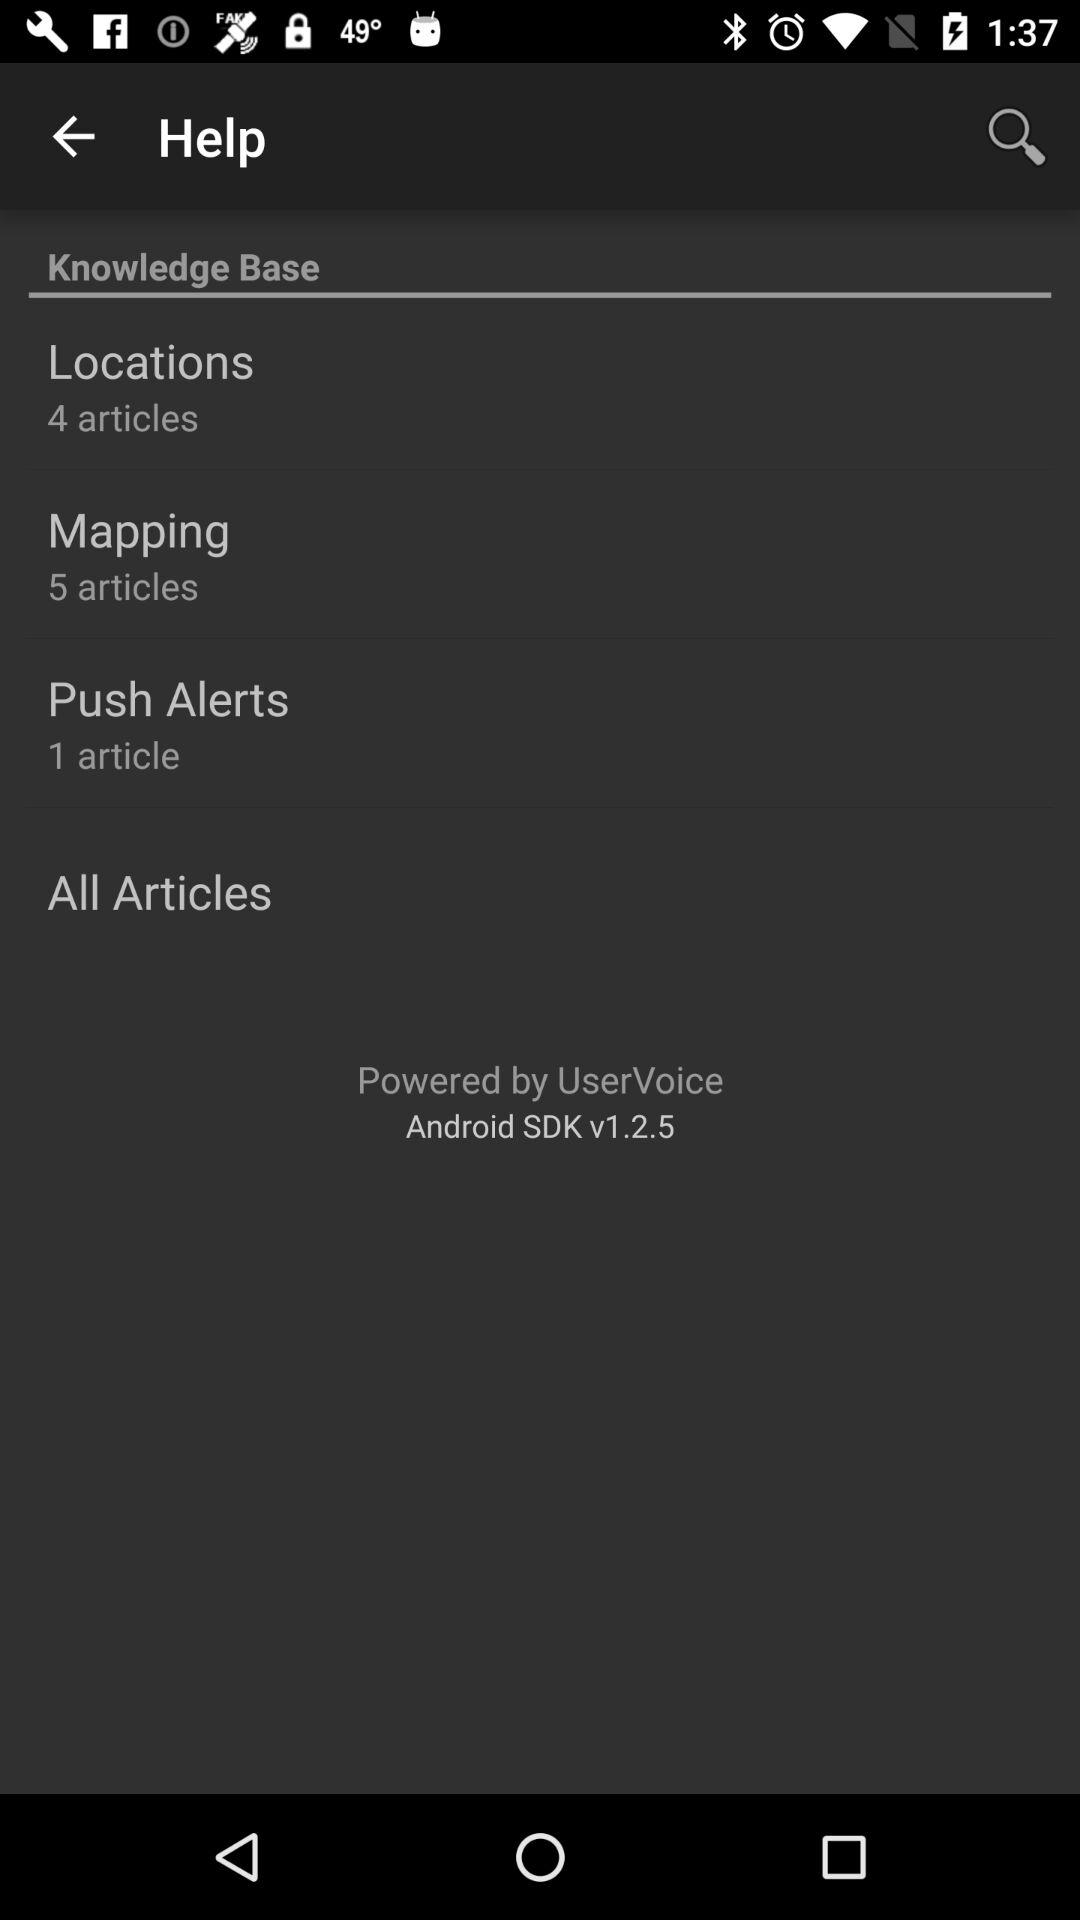Is there any branding or identification visible? Yes, the menu contains branding at the bottom, which reads 'Powered by UserVoice Android SDK v1.2.5.' This indicates that UserVoice's software development kit for Android devices is used for incorporating customer feedback features into the app. 